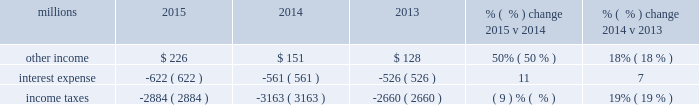Addition , fuel costs were lower as gross-ton miles decreased 9% ( 9 % ) .
The fuel consumption rate ( c-rate ) , computed as gallons of fuel consumed divided by gross ton-miles in thousands , increased 1% ( 1 % ) compared to 2014 .
Decreases in heavier , more fuel-efficient shipments , decreased gross-ton miles and increased the c-rate .
Volume growth of 7% ( 7 % ) , as measured by gross ton-miles , drove the increase in fuel expense in 2014 compared to 2013 .
This was essentially offset by lower locomotive diesel fuel prices , which averaged $ 2.97 per gallon ( including taxes and transportation costs ) in 2014 , compared to $ 3.15 in 2013 , along with a slight improvement in c-rate , computed as gallons of fuel consumed divided by gross ton-miles .
Depreciation 2013 the majority of depreciation relates to road property , including rail , ties , ballast , and other track material .
A higher depreciable asset base , reflecting higher capital spending in recent years , increased depreciation expense in 2015 compared to 2014 .
This increase was partially offset by our recent depreciation studies that resulted in lower depreciation rates for some asset classes .
Depreciation was up 7% ( 7 % ) in 2014 compared to 2013 .
A higher depreciable asset base , reflecting higher ongoing capital spending drove the increase .
Equipment and other rents 2013 equipment and other rents expense primarily includes rental expense that the railroad pays for freight cars owned by other railroads or private companies ; freight car , intermodal , and locomotive leases ; and office and other rent expenses .
Equipment and other rents expense decreased $ 4 million compared to 2014 primarily from a decrease in manifest and intermodal shipments , partially offset by growth in finished vehicle shipments .
Higher intermodal volumes and longer cycle times increased short-term freight car rental expense in 2014 compared to 2013 .
Lower equipment leases essentially offset the higher freight car rental expense , as we exercised purchase options on some of our leased equipment .
Other 2013 other expenses include state and local taxes , freight , equipment and property damage , utilities , insurance , personal injury , environmental , employee travel , telephone and cellular , computer software , bad debt , and other general expenses .
Other expenses were flat in 2015 compared to 2014 as higher property taxes were offset by lower costs in other areas .
Higher property taxes , personal injury expense and utilities costs partially offset by lower environmental expense and costs associated with damaged freight resulted in an increase in other costs in 2014 compared to 2013 .
Non-operating items % (  % ) change % (  % ) change millions 2015 2014 2013 2015 v 2014 2014 v 2013 .
Other income 2013 other income increased in 2015 compared to 2014 primarily due to a $ 113 million gain from a real estate sale in the second quarter of 2015 , partially offset by a gain from the sale of a permanent easement in 2014 .
Other income increased in 2014 versus 2013 due to higher gains from real estate sales and a sale of a permanent easement .
These gains were partially offset by higher environmental costs on non-operating property in 2014 and lower lease income due to the $ 17 million settlement of a land lease contract in interest expense 2013 interest expense increased in 2015 compared to 2014 due to an increased weighted- average debt level of $ 13.0 billion in 2015 from $ 10.7 billion in 2014 , partially offset by the impact of a lower effective interest rate of 4.8% ( 4.8 % ) in 2015 compared to 5.3% ( 5.3 % ) in 2014 .
Interest expense increased in 2014 versus 2013 due to an increased weighted-average debt level of $ 10.7 billion in 2014 from $ 9.6 billion in 2013 , which more than offset the impact of the lower effective interest rate of 5.3% ( 5.3 % ) in 2014 versus 5.7% ( 5.7 % ) in 2013. .
What was the change in millions in other income from 2014 to 2015? 
Computations: (226 - 151)
Answer: 75.0. 